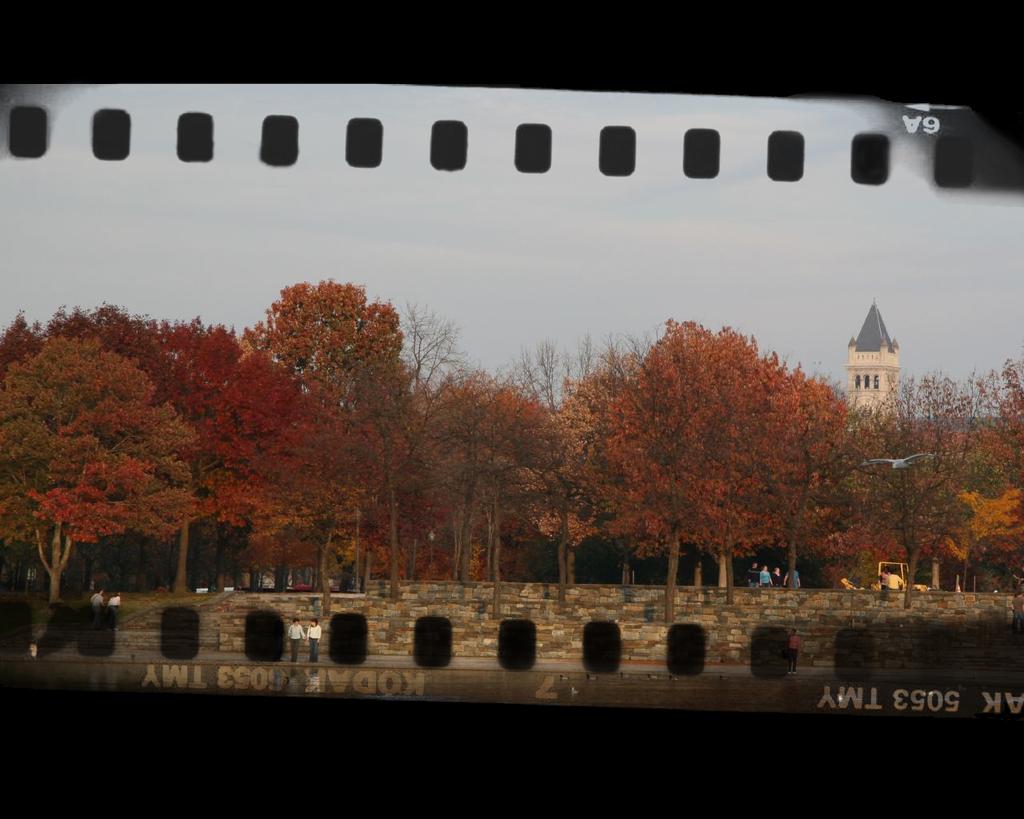What brand is the film?
Provide a succinct answer. Kodak. What is the serial number beside the film brand?
Make the answer very short. 5053 tmy. 